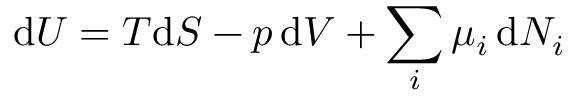<formula> <loc_0><loc_0><loc_500><loc_500>d U = T d S - p \, d V + \sum _ { i } \mu _ { i } \, d N _ { i }</formula> 